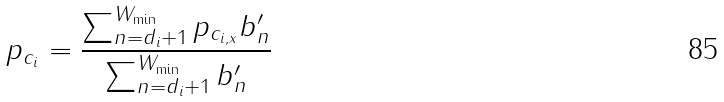<formula> <loc_0><loc_0><loc_500><loc_500>p _ { c _ { i } } = \frac { \sum _ { n = d _ { i } + 1 } ^ { W _ { \min } } p _ { c _ { i , x } } b ^ { \prime } _ { n } } { \sum _ { n = d _ { i } + 1 } ^ { W _ { \min } } b ^ { \prime } _ { n } }</formula> 